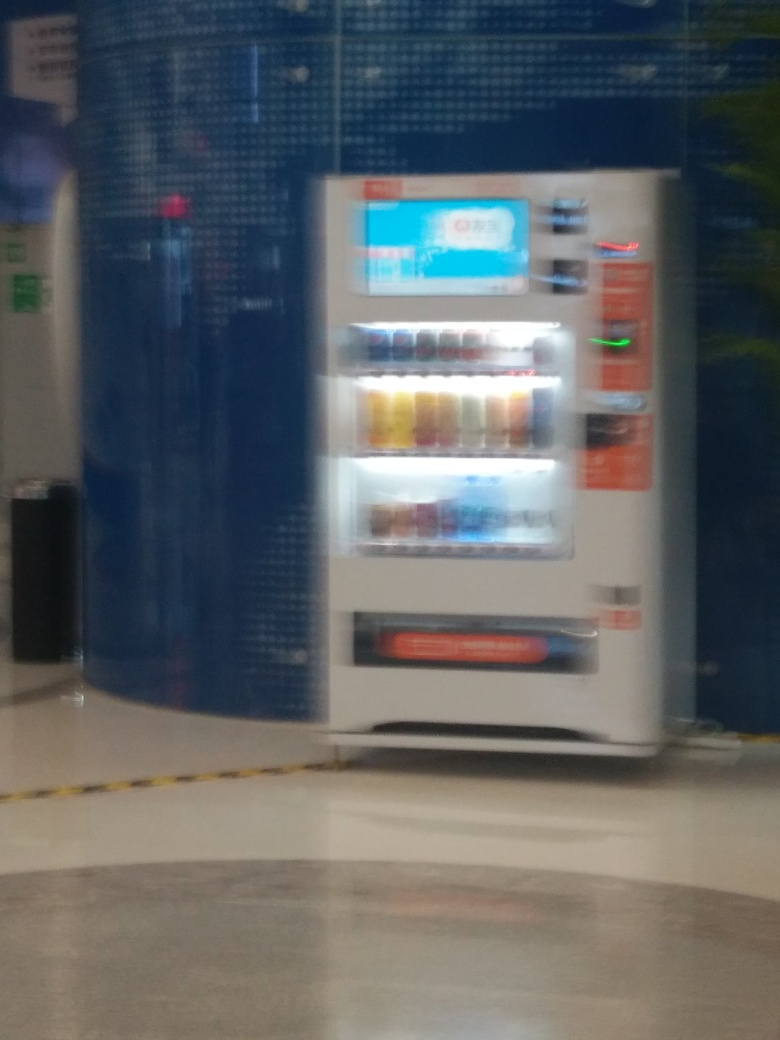Are there any lens flares?
 No 